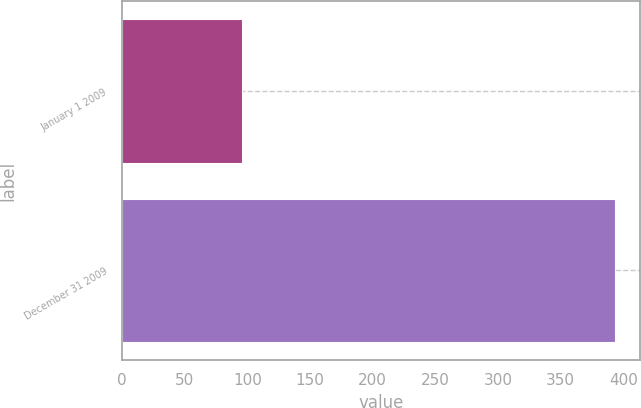<chart> <loc_0><loc_0><loc_500><loc_500><bar_chart><fcel>January 1 2009<fcel>December 31 2009<nl><fcel>95.8<fcel>393.6<nl></chart> 